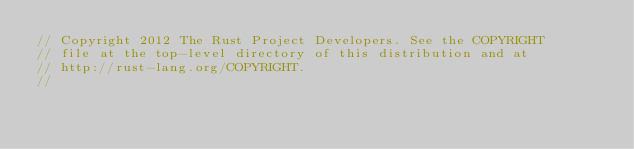<code> <loc_0><loc_0><loc_500><loc_500><_Rust_>// Copyright 2012 The Rust Project Developers. See the COPYRIGHT
// file at the top-level directory of this distribution and at
// http://rust-lang.org/COPYRIGHT.
//</code> 